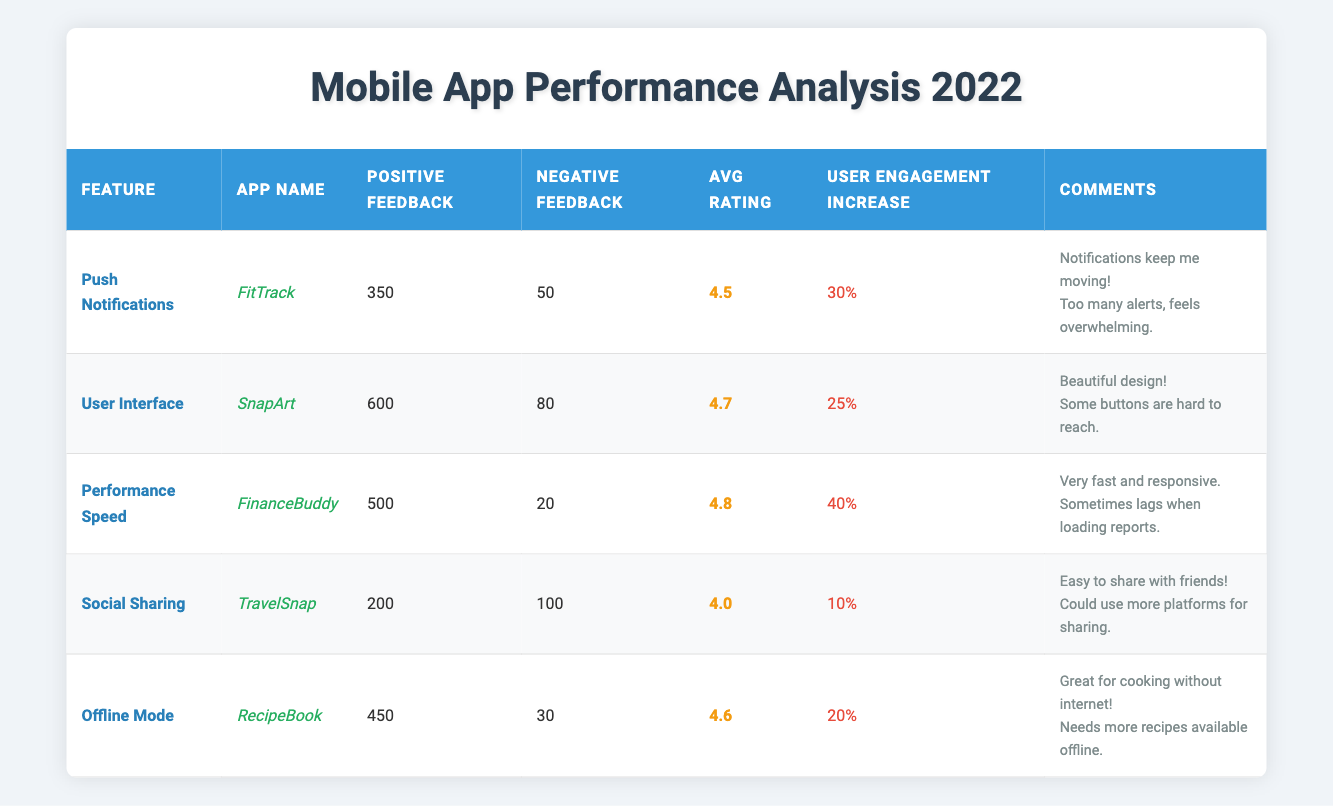What is the average rating of the feature "User Interface" for the app "SnapArt"? The average rating for the feature "User Interface" under the app "SnapArt" is explicitly stated in the table as 4.7.
Answer: 4.7 Which feature of the app "TravelSnap" received more negative feedback than positive feedback? The feature "Social Sharing" for the app "TravelSnap" received 100 negative feedback compared to 200 positive feedback, making it the only feature with such a high proportion of negative feedback in this app.
Answer: Social Sharing How many total positive feedbacks are there across all features? To find the total positive feedback, sum all the positive feedback values: 350 (Push Notifications) + 600 (User Interface) + 500 (Performance Speed) + 200 (Social Sharing) + 450 (Offline Mode) = 2100.
Answer: 2100 For which feature did the highest user engagement increase occur based on user feedback? The feature "Performance Speed" for the app "FinanceBuddy" shows the highest user engagement increase of 40%, compared to other features listed in the table.
Answer: Performance Speed Is the average rating for the feature "Offline Mode" higher than that of "Social Sharing"? The average rating for "Offline Mode" is 4.6 while "Social Sharing" is 4.0, indicating that yes, it is higher.
Answer: Yes What is the difference in positive feedback between "User Interface" and "Performance Speed"? The positive feedback for "User Interface" is 600 while for "Performance Speed" it is 500. The difference is calculated as: 600 - 500 = 100.
Answer: 100 Identify the app with the lowest average rating among the listed features. "Social Sharing" from the app "TravelSnap" has the lowest average rating of 4.0 compared to all other features which are above that value.
Answer: TravelSnap What percentage of the total feedback (positive and negative) does the negative feedback for "Push Notifications" represent? "Push Notifications" received 350 positive feedback and 50 negative feedback, meaning the total feedback is 350 + 50 = 400. The percentage of negative feedback is (50/400) * 100 = 12.5%.
Answer: 12.5% 